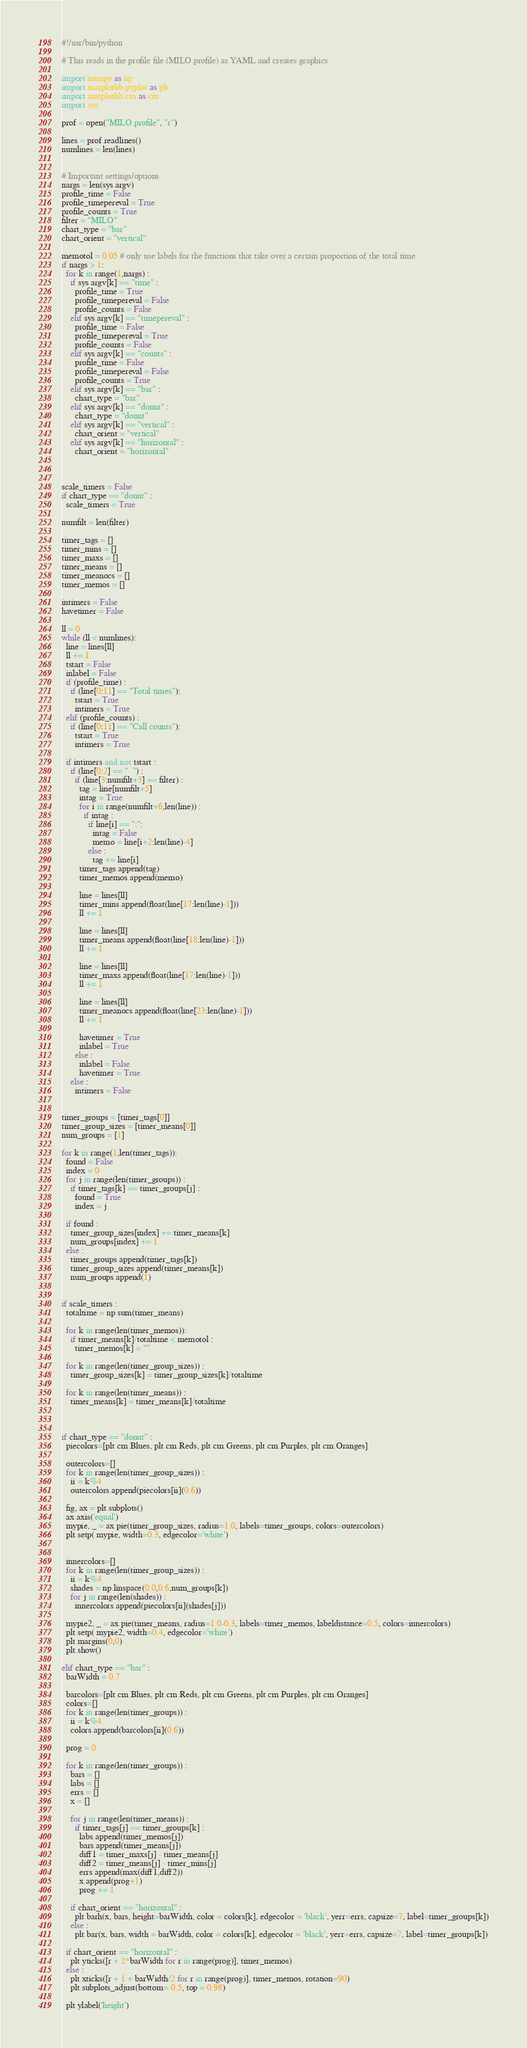<code> <loc_0><loc_0><loc_500><loc_500><_Python_>#!/usr/bin/python

# This reads in the profile file (MILO.profile) as YAML and creates graphics

import numpy as np
import matplotlib.pyplot as plt
import matplotlib.cm as cm
import sys

prof = open("MILO.profile", "r")

lines = prof.readlines()
numlines = len(lines)


# Important settings/options
nargs = len(sys.argv)
profile_time = False
profile_timepereval = True
profile_counts = True
filter = "MILO"
chart_type = "bar"
chart_orient = "vertical"

memotol = 0.05 # only use labels for the functions that take over a certain proportion of the total time
if nargs > 1:
  for k in range(1,nargs) :
    if sys.argv[k] == "time" :
      profile_time = True
      profile_timepereval = False
      profile_counts = False
    elif sys.argv[k] == "timepereval" :
      profile_time = False
      profile_timepereval = True
      profile_counts = False
    elif sys.argv[k] == "counts" :
      profile_time = False
      profile_timepereval = False
      profile_counts = True
    elif sys.argv[k] == "bar" :
      chart_type = "bar"
    elif sys.argv[k] == "donut" :
      chart_type = "donut"
    elif sys.argv[k] == "vertical" :
      chart_orient = "vertical"
    elif sys.argv[k] == "horizontal" :
      chart_orient = "horizontal"



scale_timers = False
if chart_type == "donut" :
  scale_timers = True

numfilt = len(filter)

timer_tags = []
timer_mins = []
timer_maxs = []
timer_means = []
timer_meanocs = []
timer_memos = []

intimers = False
havetimer = False
  
ll = 0
while (ll < numlines):
  line = lines[ll]
  ll += 1
  tstart = False
  inlabel = False
  if (profile_time) :
    if (line[0:11] == "Total times"):
      tstart = True
      intimers = True
  elif (profile_counts) :
    if (line[0:11] == "Call counts"):
      tstart = True
      intimers = True
    
  if intimers and not tstart :
    if (line[0:2] == "  ") :
      if (line[3:numfilt+3] == filter) :
        tag = line[numfilt+5]
        intag = True
        for i in range(numfilt+6,len(line)) :
          if intag :
            if line[i] == ":":
              intag = False
              memo = line[i+2:len(line)-4]
            else :
              tag += line[i]
        timer_tags.append(tag)
        timer_memos.append(memo)
          
        line = lines[ll]
        timer_mins.append(float(line[17:len(line)-1]))
        ll += 1
          
        line = lines[ll]
        timer_means.append(float(line[18:len(line)-1]))
        ll += 1
          
        line = lines[ll]
        timer_maxs.append(float(line[17:len(line)-1]))
        ll += 1
          
        line = lines[ll]
        timer_meanocs.append(float(line[23:len(line)-1]))
        ll += 1
          
        havetimer = True
        inlabel = True
      else :
        inlabel = False
        havetimer = True
    else :
      intimers = False


timer_groups = [timer_tags[0]]
timer_group_sizes = [timer_means[0]]
num_groups = [1]

for k in range(1,len(timer_tags)):
  found = False
  index = 0
  for j in range(len(timer_groups)) :
    if timer_tags[k] == timer_groups[j] :
      found = True
      index = j

  if found :
    timer_group_sizes[index] += timer_means[k]
    num_groups[index] += 1
  else :
    timer_groups.append(timer_tags[k])
    timer_group_sizes.append(timer_means[k])
    num_groups.append(1)


if scale_timers :
  totaltime = np.sum(timer_means)

  for k in range(len(timer_memos)):
    if timer_means[k]/totaltime < memotol :
      timer_memos[k] = ""

  for k in range(len(timer_group_sizes)) :
    timer_group_sizes[k] = timer_group_sizes[k]/totaltime

  for k in range(len(timer_means)) :
    timer_means[k] = timer_means[k]/totaltime



if chart_type == "donut" :
  piecolors=[plt.cm.Blues, plt.cm.Reds, plt.cm.Greens, plt.cm.Purples, plt.cm.Oranges]

  outercolors=[]
  for k in range(len(timer_group_sizes)) :
    ii = k%4
    outercolors.append(piecolors[ii](0.6))

  fig, ax = plt.subplots()
  ax.axis('equal')
  mypie, _ = ax.pie(timer_group_sizes, radius=1.0, labels=timer_groups, colors=outercolors)
  plt.setp( mypie, width=0.3, edgecolor='white')


  innercolors=[]
  for k in range(len(timer_group_sizes)) :
    ii = k%4
    shades = np.linspace(0.0,0.6,num_groups[k])
    for j in range(len(shades)) :
      innercolors.append(piecolors[ii](shades[j]))

  mypie2, _ = ax.pie(timer_means, radius=1.0-0.3, labels=timer_memos, labeldistance=0.5, colors=innercolors)
  plt.setp( mypie2, width=0.4, edgecolor='white')
  plt.margins(0,0)
  plt.show()

elif chart_type == "bar" :
  barWidth = 0.7

  barcolors=[plt.cm.Blues, plt.cm.Reds, plt.cm.Greens, plt.cm.Purples, plt.cm.Oranges]
  colors=[]
  for k in range(len(timer_groups)) :
    ii = k%4
    colors.append(barcolors[ii](0.6))
  
  prog = 0

  for k in range(len(timer_groups)) :
    bars = []
    labs = []
    errs = []
    x = []

    for j in range(len(timer_means)) :
      if timer_tags[j] == timer_groups[k] :
        labs.append(timer_memos[j])
        bars.append(timer_means[j])
        diff1 = timer_maxs[j] - timer_means[j]
        diff2 = timer_means[j] - timer_mins[j]
        errs.append(max(diff1,diff2))
        x.append(prog+1)
        prog += 1

    if chart_orient == "horizontal" :
      plt.barh(x, bars, height=barWidth, color = colors[k], edgecolor = 'black', yerr=errs, capsize=7, label=timer_groups[k])
    else :
      plt.bar(x, bars, width = barWidth, color = colors[k], edgecolor = 'black', yerr=errs, capsize=7, label=timer_groups[k])

  if chart_orient == "horizontal" :
    plt.yticks([r + 2*barWidth for r in range(prog)], timer_memos)
  else :
    plt.xticks([r + 1 + barWidth/2 for r in range(prog)], timer_memos, rotation=90)
    plt.subplots_adjust(bottom= 0.5, top = 0.98)

  plt.ylabel('height')</code> 